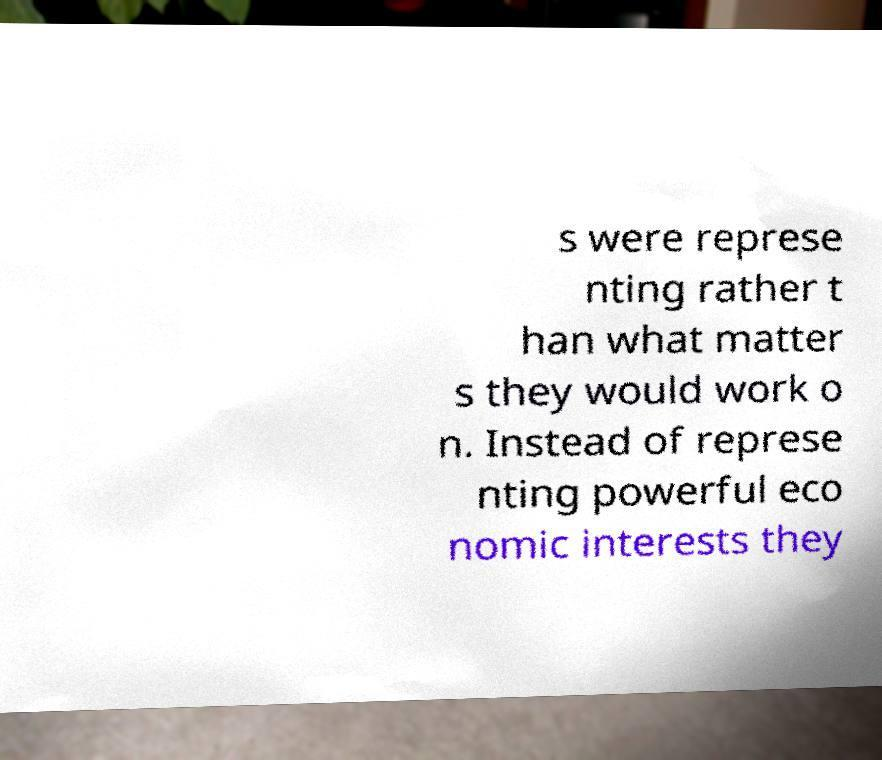I need the written content from this picture converted into text. Can you do that? s were represe nting rather t han what matter s they would work o n. Instead of represe nting powerful eco nomic interests they 